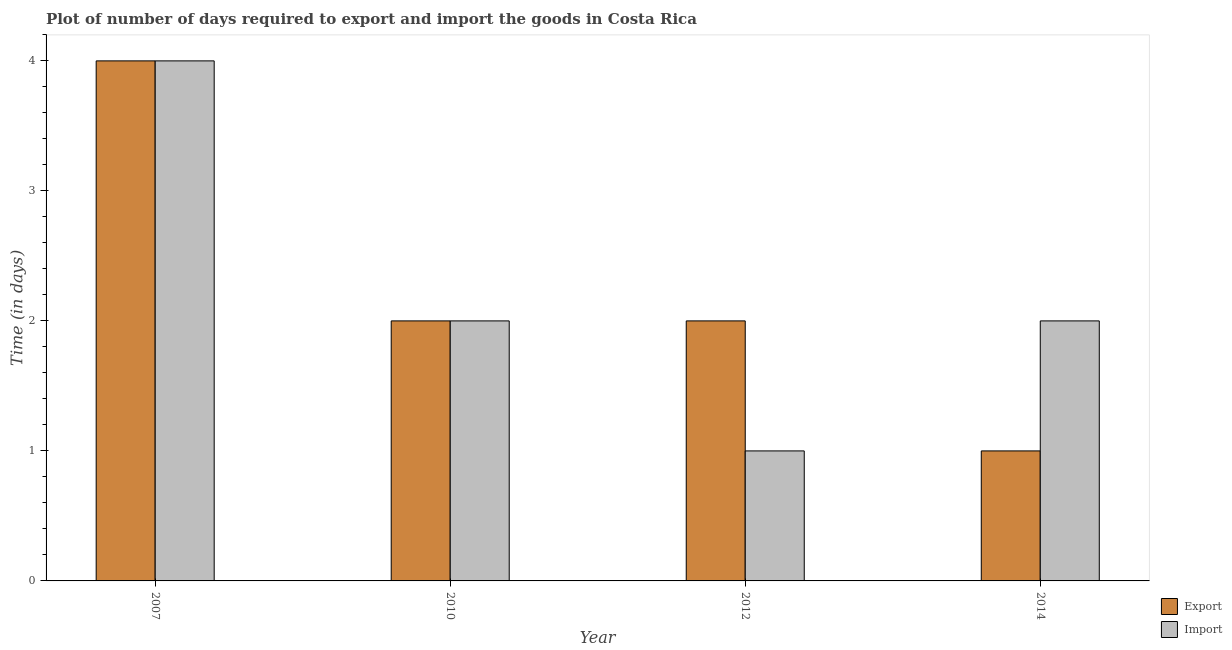Are the number of bars per tick equal to the number of legend labels?
Your answer should be compact. Yes. How many bars are there on the 4th tick from the left?
Ensure brevity in your answer.  2. How many bars are there on the 2nd tick from the right?
Give a very brief answer. 2. What is the label of the 1st group of bars from the left?
Ensure brevity in your answer.  2007. What is the time required to import in 2007?
Keep it short and to the point. 4. Across all years, what is the maximum time required to export?
Ensure brevity in your answer.  4. Across all years, what is the minimum time required to export?
Your answer should be very brief. 1. In which year was the time required to import maximum?
Make the answer very short. 2007. What is the total time required to import in the graph?
Your answer should be compact. 9. What is the difference between the time required to import in 2010 and that in 2014?
Offer a very short reply. 0. What is the difference between the time required to import in 2012 and the time required to export in 2014?
Ensure brevity in your answer.  -1. What is the average time required to export per year?
Provide a short and direct response. 2.25. In the year 2012, what is the difference between the time required to import and time required to export?
Offer a terse response. 0. In how many years, is the time required to export greater than 1.6 days?
Offer a very short reply. 3. What is the ratio of the time required to import in 2010 to that in 2012?
Ensure brevity in your answer.  2. Is the difference between the time required to import in 2007 and 2010 greater than the difference between the time required to export in 2007 and 2010?
Give a very brief answer. No. What is the difference between the highest and the second highest time required to export?
Give a very brief answer. 2. What is the difference between the highest and the lowest time required to export?
Your answer should be compact. 3. Is the sum of the time required to export in 2012 and 2014 greater than the maximum time required to import across all years?
Offer a very short reply. No. What does the 2nd bar from the left in 2012 represents?
Make the answer very short. Import. What does the 1st bar from the right in 2012 represents?
Make the answer very short. Import. How many bars are there?
Give a very brief answer. 8. Are all the bars in the graph horizontal?
Your response must be concise. No. Are the values on the major ticks of Y-axis written in scientific E-notation?
Provide a succinct answer. No. Does the graph contain grids?
Ensure brevity in your answer.  No. Where does the legend appear in the graph?
Make the answer very short. Bottom right. What is the title of the graph?
Provide a succinct answer. Plot of number of days required to export and import the goods in Costa Rica. What is the label or title of the Y-axis?
Keep it short and to the point. Time (in days). What is the Time (in days) of Export in 2007?
Provide a short and direct response. 4. What is the Time (in days) in Import in 2012?
Offer a very short reply. 1. What is the Time (in days) in Export in 2014?
Make the answer very short. 1. Across all years, what is the minimum Time (in days) of Import?
Your response must be concise. 1. What is the difference between the Time (in days) of Import in 2007 and that in 2010?
Make the answer very short. 2. What is the difference between the Time (in days) in Export in 2007 and that in 2014?
Make the answer very short. 3. What is the difference between the Time (in days) in Import in 2010 and that in 2012?
Your answer should be very brief. 1. What is the difference between the Time (in days) in Import in 2010 and that in 2014?
Provide a short and direct response. 0. What is the difference between the Time (in days) in Export in 2007 and the Time (in days) in Import in 2012?
Ensure brevity in your answer.  3. What is the difference between the Time (in days) of Export in 2007 and the Time (in days) of Import in 2014?
Your answer should be very brief. 2. What is the difference between the Time (in days) of Export in 2012 and the Time (in days) of Import in 2014?
Make the answer very short. 0. What is the average Time (in days) of Export per year?
Keep it short and to the point. 2.25. What is the average Time (in days) in Import per year?
Your answer should be compact. 2.25. In the year 2007, what is the difference between the Time (in days) in Export and Time (in days) in Import?
Offer a very short reply. 0. In the year 2010, what is the difference between the Time (in days) of Export and Time (in days) of Import?
Your response must be concise. 0. What is the ratio of the Time (in days) in Import in 2007 to that in 2012?
Ensure brevity in your answer.  4. What is the ratio of the Time (in days) of Import in 2007 to that in 2014?
Your answer should be very brief. 2. What is the ratio of the Time (in days) of Import in 2010 to that in 2012?
Keep it short and to the point. 2. What is the ratio of the Time (in days) of Export in 2010 to that in 2014?
Your answer should be very brief. 2. What is the ratio of the Time (in days) in Import in 2010 to that in 2014?
Offer a very short reply. 1. What is the difference between the highest and the second highest Time (in days) in Import?
Your answer should be very brief. 2. What is the difference between the highest and the lowest Time (in days) in Export?
Offer a very short reply. 3. What is the difference between the highest and the lowest Time (in days) of Import?
Provide a succinct answer. 3. 